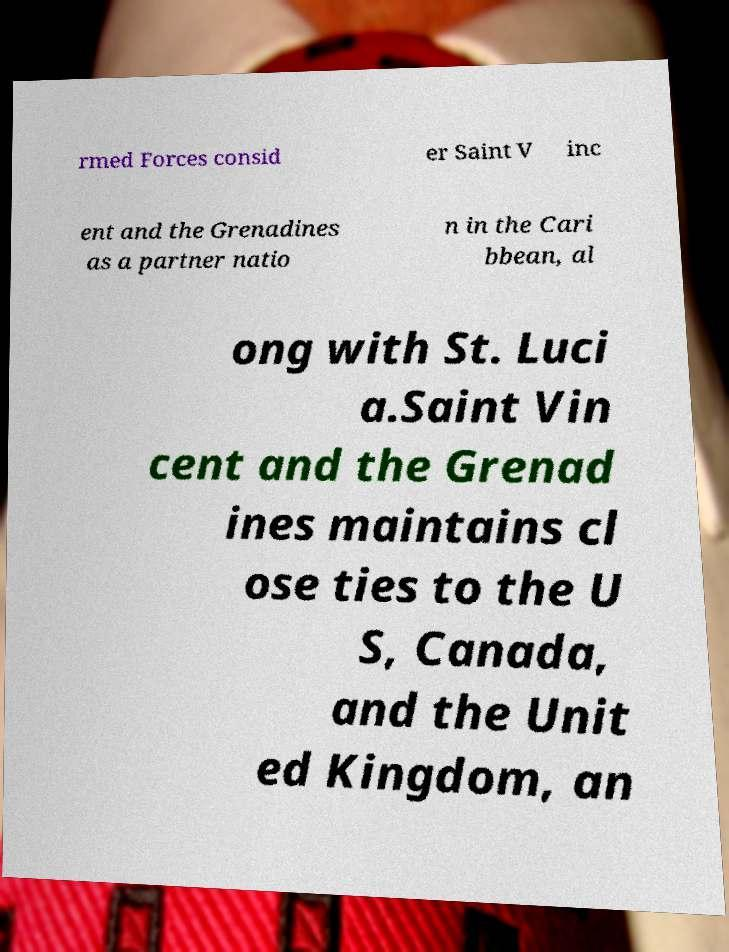Could you assist in decoding the text presented in this image and type it out clearly? rmed Forces consid er Saint V inc ent and the Grenadines as a partner natio n in the Cari bbean, al ong with St. Luci a.Saint Vin cent and the Grenad ines maintains cl ose ties to the U S, Canada, and the Unit ed Kingdom, an 